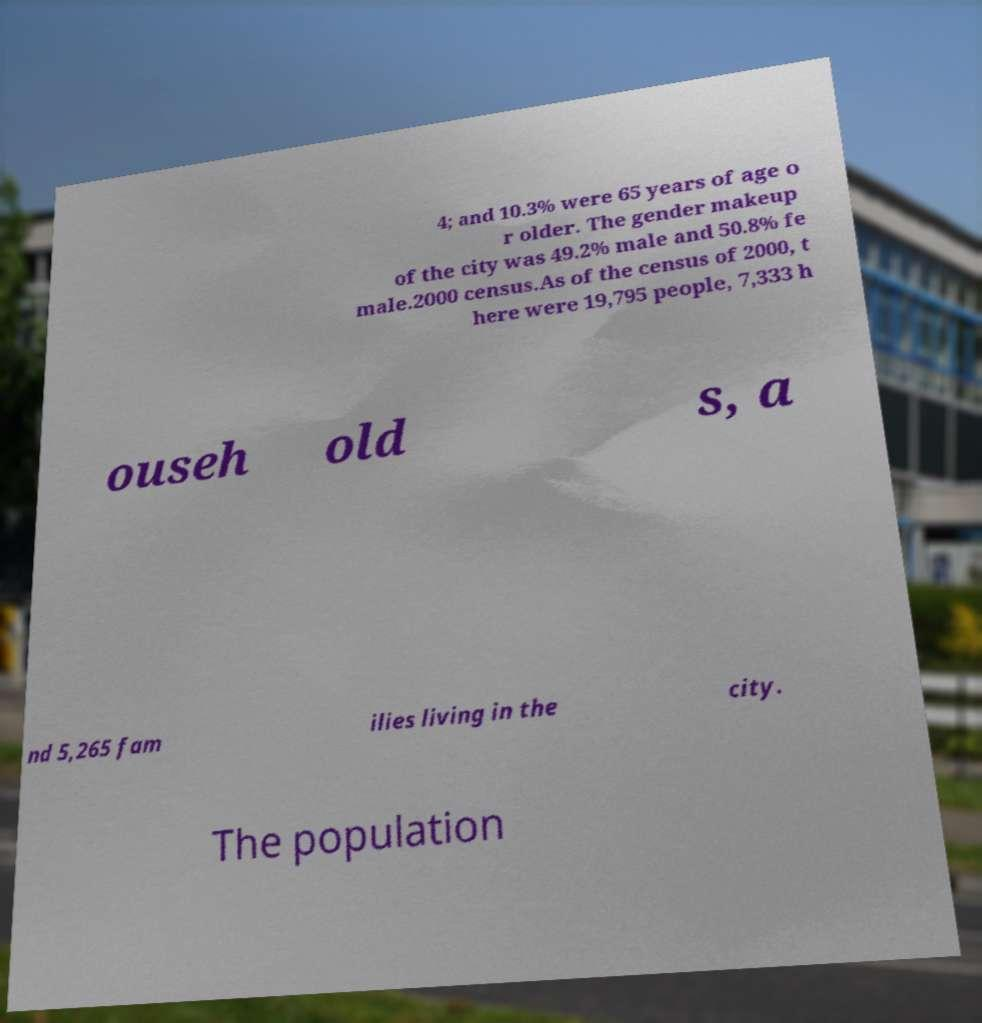Could you assist in decoding the text presented in this image and type it out clearly? 4; and 10.3% were 65 years of age o r older. The gender makeup of the city was 49.2% male and 50.8% fe male.2000 census.As of the census of 2000, t here were 19,795 people, 7,333 h ouseh old s, a nd 5,265 fam ilies living in the city. The population 